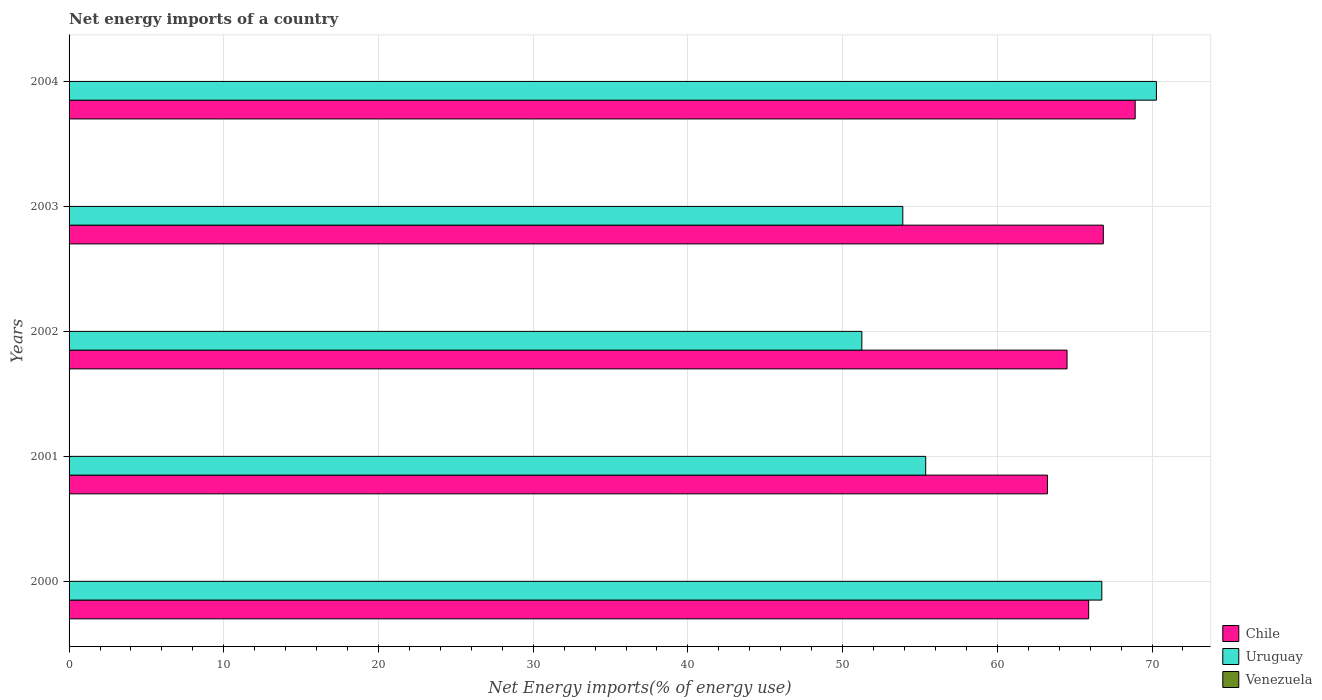Are the number of bars on each tick of the Y-axis equal?
Keep it short and to the point. Yes. How many bars are there on the 3rd tick from the top?
Ensure brevity in your answer.  2. How many bars are there on the 5th tick from the bottom?
Offer a terse response. 2. What is the label of the 2nd group of bars from the top?
Provide a short and direct response. 2003. What is the net energy imports in Uruguay in 2001?
Ensure brevity in your answer.  55.37. Across all years, what is the maximum net energy imports in Uruguay?
Provide a short and direct response. 70.29. In which year was the net energy imports in Chile maximum?
Your answer should be compact. 2004. What is the total net energy imports in Uruguay in the graph?
Give a very brief answer. 297.55. What is the difference between the net energy imports in Uruguay in 2001 and that in 2002?
Offer a very short reply. 4.13. What is the difference between the net energy imports in Chile in 2004 and the net energy imports in Venezuela in 2003?
Provide a short and direct response. 68.91. In the year 2004, what is the difference between the net energy imports in Uruguay and net energy imports in Chile?
Your answer should be very brief. 1.37. In how many years, is the net energy imports in Chile greater than 12 %?
Make the answer very short. 5. What is the ratio of the net energy imports in Chile in 2003 to that in 2004?
Give a very brief answer. 0.97. Is the difference between the net energy imports in Uruguay in 2000 and 2003 greater than the difference between the net energy imports in Chile in 2000 and 2003?
Keep it short and to the point. Yes. What is the difference between the highest and the second highest net energy imports in Chile?
Keep it short and to the point. 2.06. What is the difference between the highest and the lowest net energy imports in Uruguay?
Give a very brief answer. 19.04. In how many years, is the net energy imports in Venezuela greater than the average net energy imports in Venezuela taken over all years?
Your answer should be compact. 0. Is the sum of the net energy imports in Uruguay in 2001 and 2002 greater than the maximum net energy imports in Venezuela across all years?
Your answer should be compact. Yes. Is it the case that in every year, the sum of the net energy imports in Chile and net energy imports in Venezuela is greater than the net energy imports in Uruguay?
Keep it short and to the point. No. How many bars are there?
Keep it short and to the point. 10. How many years are there in the graph?
Your answer should be compact. 5. Does the graph contain any zero values?
Your answer should be very brief. Yes. Does the graph contain grids?
Offer a very short reply. Yes. How many legend labels are there?
Give a very brief answer. 3. What is the title of the graph?
Make the answer very short. Net energy imports of a country. What is the label or title of the X-axis?
Your answer should be compact. Net Energy imports(% of energy use). What is the Net Energy imports(% of energy use) of Chile in 2000?
Your answer should be very brief. 65.91. What is the Net Energy imports(% of energy use) of Uruguay in 2000?
Your answer should be compact. 66.76. What is the Net Energy imports(% of energy use) of Chile in 2001?
Give a very brief answer. 63.24. What is the Net Energy imports(% of energy use) of Uruguay in 2001?
Provide a short and direct response. 55.37. What is the Net Energy imports(% of energy use) in Venezuela in 2001?
Offer a terse response. 0. What is the Net Energy imports(% of energy use) of Chile in 2002?
Your answer should be very brief. 64.51. What is the Net Energy imports(% of energy use) of Uruguay in 2002?
Your response must be concise. 51.25. What is the Net Energy imports(% of energy use) of Chile in 2003?
Your answer should be compact. 66.85. What is the Net Energy imports(% of energy use) in Uruguay in 2003?
Provide a short and direct response. 53.89. What is the Net Energy imports(% of energy use) in Venezuela in 2003?
Your answer should be compact. 0. What is the Net Energy imports(% of energy use) of Chile in 2004?
Keep it short and to the point. 68.91. What is the Net Energy imports(% of energy use) of Uruguay in 2004?
Give a very brief answer. 70.29. Across all years, what is the maximum Net Energy imports(% of energy use) of Chile?
Offer a very short reply. 68.91. Across all years, what is the maximum Net Energy imports(% of energy use) in Uruguay?
Your answer should be compact. 70.29. Across all years, what is the minimum Net Energy imports(% of energy use) of Chile?
Your answer should be compact. 63.24. Across all years, what is the minimum Net Energy imports(% of energy use) of Uruguay?
Ensure brevity in your answer.  51.25. What is the total Net Energy imports(% of energy use) in Chile in the graph?
Your answer should be compact. 329.42. What is the total Net Energy imports(% of energy use) of Uruguay in the graph?
Offer a terse response. 297.55. What is the difference between the Net Energy imports(% of energy use) in Chile in 2000 and that in 2001?
Provide a succinct answer. 2.67. What is the difference between the Net Energy imports(% of energy use) of Uruguay in 2000 and that in 2001?
Keep it short and to the point. 11.39. What is the difference between the Net Energy imports(% of energy use) in Chile in 2000 and that in 2002?
Provide a succinct answer. 1.4. What is the difference between the Net Energy imports(% of energy use) of Uruguay in 2000 and that in 2002?
Your response must be concise. 15.51. What is the difference between the Net Energy imports(% of energy use) in Chile in 2000 and that in 2003?
Give a very brief answer. -0.95. What is the difference between the Net Energy imports(% of energy use) of Uruguay in 2000 and that in 2003?
Your answer should be compact. 12.87. What is the difference between the Net Energy imports(% of energy use) in Chile in 2000 and that in 2004?
Make the answer very short. -3.01. What is the difference between the Net Energy imports(% of energy use) of Uruguay in 2000 and that in 2004?
Offer a very short reply. -3.53. What is the difference between the Net Energy imports(% of energy use) in Chile in 2001 and that in 2002?
Keep it short and to the point. -1.27. What is the difference between the Net Energy imports(% of energy use) of Uruguay in 2001 and that in 2002?
Offer a very short reply. 4.13. What is the difference between the Net Energy imports(% of energy use) in Chile in 2001 and that in 2003?
Provide a succinct answer. -3.61. What is the difference between the Net Energy imports(% of energy use) in Uruguay in 2001 and that in 2003?
Give a very brief answer. 1.48. What is the difference between the Net Energy imports(% of energy use) of Chile in 2001 and that in 2004?
Give a very brief answer. -5.67. What is the difference between the Net Energy imports(% of energy use) in Uruguay in 2001 and that in 2004?
Offer a very short reply. -14.91. What is the difference between the Net Energy imports(% of energy use) in Chile in 2002 and that in 2003?
Your answer should be very brief. -2.35. What is the difference between the Net Energy imports(% of energy use) of Uruguay in 2002 and that in 2003?
Keep it short and to the point. -2.65. What is the difference between the Net Energy imports(% of energy use) in Chile in 2002 and that in 2004?
Your answer should be very brief. -4.4. What is the difference between the Net Energy imports(% of energy use) of Uruguay in 2002 and that in 2004?
Your answer should be compact. -19.04. What is the difference between the Net Energy imports(% of energy use) in Chile in 2003 and that in 2004?
Ensure brevity in your answer.  -2.06. What is the difference between the Net Energy imports(% of energy use) in Uruguay in 2003 and that in 2004?
Keep it short and to the point. -16.39. What is the difference between the Net Energy imports(% of energy use) in Chile in 2000 and the Net Energy imports(% of energy use) in Uruguay in 2001?
Offer a terse response. 10.53. What is the difference between the Net Energy imports(% of energy use) of Chile in 2000 and the Net Energy imports(% of energy use) of Uruguay in 2002?
Provide a short and direct response. 14.66. What is the difference between the Net Energy imports(% of energy use) of Chile in 2000 and the Net Energy imports(% of energy use) of Uruguay in 2003?
Give a very brief answer. 12.02. What is the difference between the Net Energy imports(% of energy use) in Chile in 2000 and the Net Energy imports(% of energy use) in Uruguay in 2004?
Offer a terse response. -4.38. What is the difference between the Net Energy imports(% of energy use) in Chile in 2001 and the Net Energy imports(% of energy use) in Uruguay in 2002?
Your answer should be very brief. 12. What is the difference between the Net Energy imports(% of energy use) of Chile in 2001 and the Net Energy imports(% of energy use) of Uruguay in 2003?
Offer a terse response. 9.35. What is the difference between the Net Energy imports(% of energy use) of Chile in 2001 and the Net Energy imports(% of energy use) of Uruguay in 2004?
Keep it short and to the point. -7.04. What is the difference between the Net Energy imports(% of energy use) of Chile in 2002 and the Net Energy imports(% of energy use) of Uruguay in 2003?
Provide a short and direct response. 10.62. What is the difference between the Net Energy imports(% of energy use) of Chile in 2002 and the Net Energy imports(% of energy use) of Uruguay in 2004?
Your response must be concise. -5.78. What is the difference between the Net Energy imports(% of energy use) in Chile in 2003 and the Net Energy imports(% of energy use) in Uruguay in 2004?
Your answer should be very brief. -3.43. What is the average Net Energy imports(% of energy use) in Chile per year?
Give a very brief answer. 65.88. What is the average Net Energy imports(% of energy use) in Uruguay per year?
Make the answer very short. 59.51. In the year 2000, what is the difference between the Net Energy imports(% of energy use) of Chile and Net Energy imports(% of energy use) of Uruguay?
Your response must be concise. -0.85. In the year 2001, what is the difference between the Net Energy imports(% of energy use) in Chile and Net Energy imports(% of energy use) in Uruguay?
Give a very brief answer. 7.87. In the year 2002, what is the difference between the Net Energy imports(% of energy use) of Chile and Net Energy imports(% of energy use) of Uruguay?
Make the answer very short. 13.26. In the year 2003, what is the difference between the Net Energy imports(% of energy use) of Chile and Net Energy imports(% of energy use) of Uruguay?
Provide a succinct answer. 12.96. In the year 2004, what is the difference between the Net Energy imports(% of energy use) in Chile and Net Energy imports(% of energy use) in Uruguay?
Provide a succinct answer. -1.37. What is the ratio of the Net Energy imports(% of energy use) of Chile in 2000 to that in 2001?
Make the answer very short. 1.04. What is the ratio of the Net Energy imports(% of energy use) of Uruguay in 2000 to that in 2001?
Ensure brevity in your answer.  1.21. What is the ratio of the Net Energy imports(% of energy use) of Chile in 2000 to that in 2002?
Offer a terse response. 1.02. What is the ratio of the Net Energy imports(% of energy use) of Uruguay in 2000 to that in 2002?
Your response must be concise. 1.3. What is the ratio of the Net Energy imports(% of energy use) of Chile in 2000 to that in 2003?
Keep it short and to the point. 0.99. What is the ratio of the Net Energy imports(% of energy use) in Uruguay in 2000 to that in 2003?
Make the answer very short. 1.24. What is the ratio of the Net Energy imports(% of energy use) in Chile in 2000 to that in 2004?
Provide a short and direct response. 0.96. What is the ratio of the Net Energy imports(% of energy use) in Uruguay in 2000 to that in 2004?
Offer a terse response. 0.95. What is the ratio of the Net Energy imports(% of energy use) in Chile in 2001 to that in 2002?
Keep it short and to the point. 0.98. What is the ratio of the Net Energy imports(% of energy use) in Uruguay in 2001 to that in 2002?
Your answer should be compact. 1.08. What is the ratio of the Net Energy imports(% of energy use) of Chile in 2001 to that in 2003?
Provide a succinct answer. 0.95. What is the ratio of the Net Energy imports(% of energy use) of Uruguay in 2001 to that in 2003?
Provide a short and direct response. 1.03. What is the ratio of the Net Energy imports(% of energy use) in Chile in 2001 to that in 2004?
Your response must be concise. 0.92. What is the ratio of the Net Energy imports(% of energy use) in Uruguay in 2001 to that in 2004?
Keep it short and to the point. 0.79. What is the ratio of the Net Energy imports(% of energy use) of Chile in 2002 to that in 2003?
Provide a short and direct response. 0.96. What is the ratio of the Net Energy imports(% of energy use) of Uruguay in 2002 to that in 2003?
Your answer should be very brief. 0.95. What is the ratio of the Net Energy imports(% of energy use) in Chile in 2002 to that in 2004?
Your answer should be compact. 0.94. What is the ratio of the Net Energy imports(% of energy use) of Uruguay in 2002 to that in 2004?
Your response must be concise. 0.73. What is the ratio of the Net Energy imports(% of energy use) of Chile in 2003 to that in 2004?
Provide a succinct answer. 0.97. What is the ratio of the Net Energy imports(% of energy use) in Uruguay in 2003 to that in 2004?
Ensure brevity in your answer.  0.77. What is the difference between the highest and the second highest Net Energy imports(% of energy use) of Chile?
Offer a very short reply. 2.06. What is the difference between the highest and the second highest Net Energy imports(% of energy use) in Uruguay?
Your answer should be very brief. 3.53. What is the difference between the highest and the lowest Net Energy imports(% of energy use) in Chile?
Offer a terse response. 5.67. What is the difference between the highest and the lowest Net Energy imports(% of energy use) in Uruguay?
Keep it short and to the point. 19.04. 